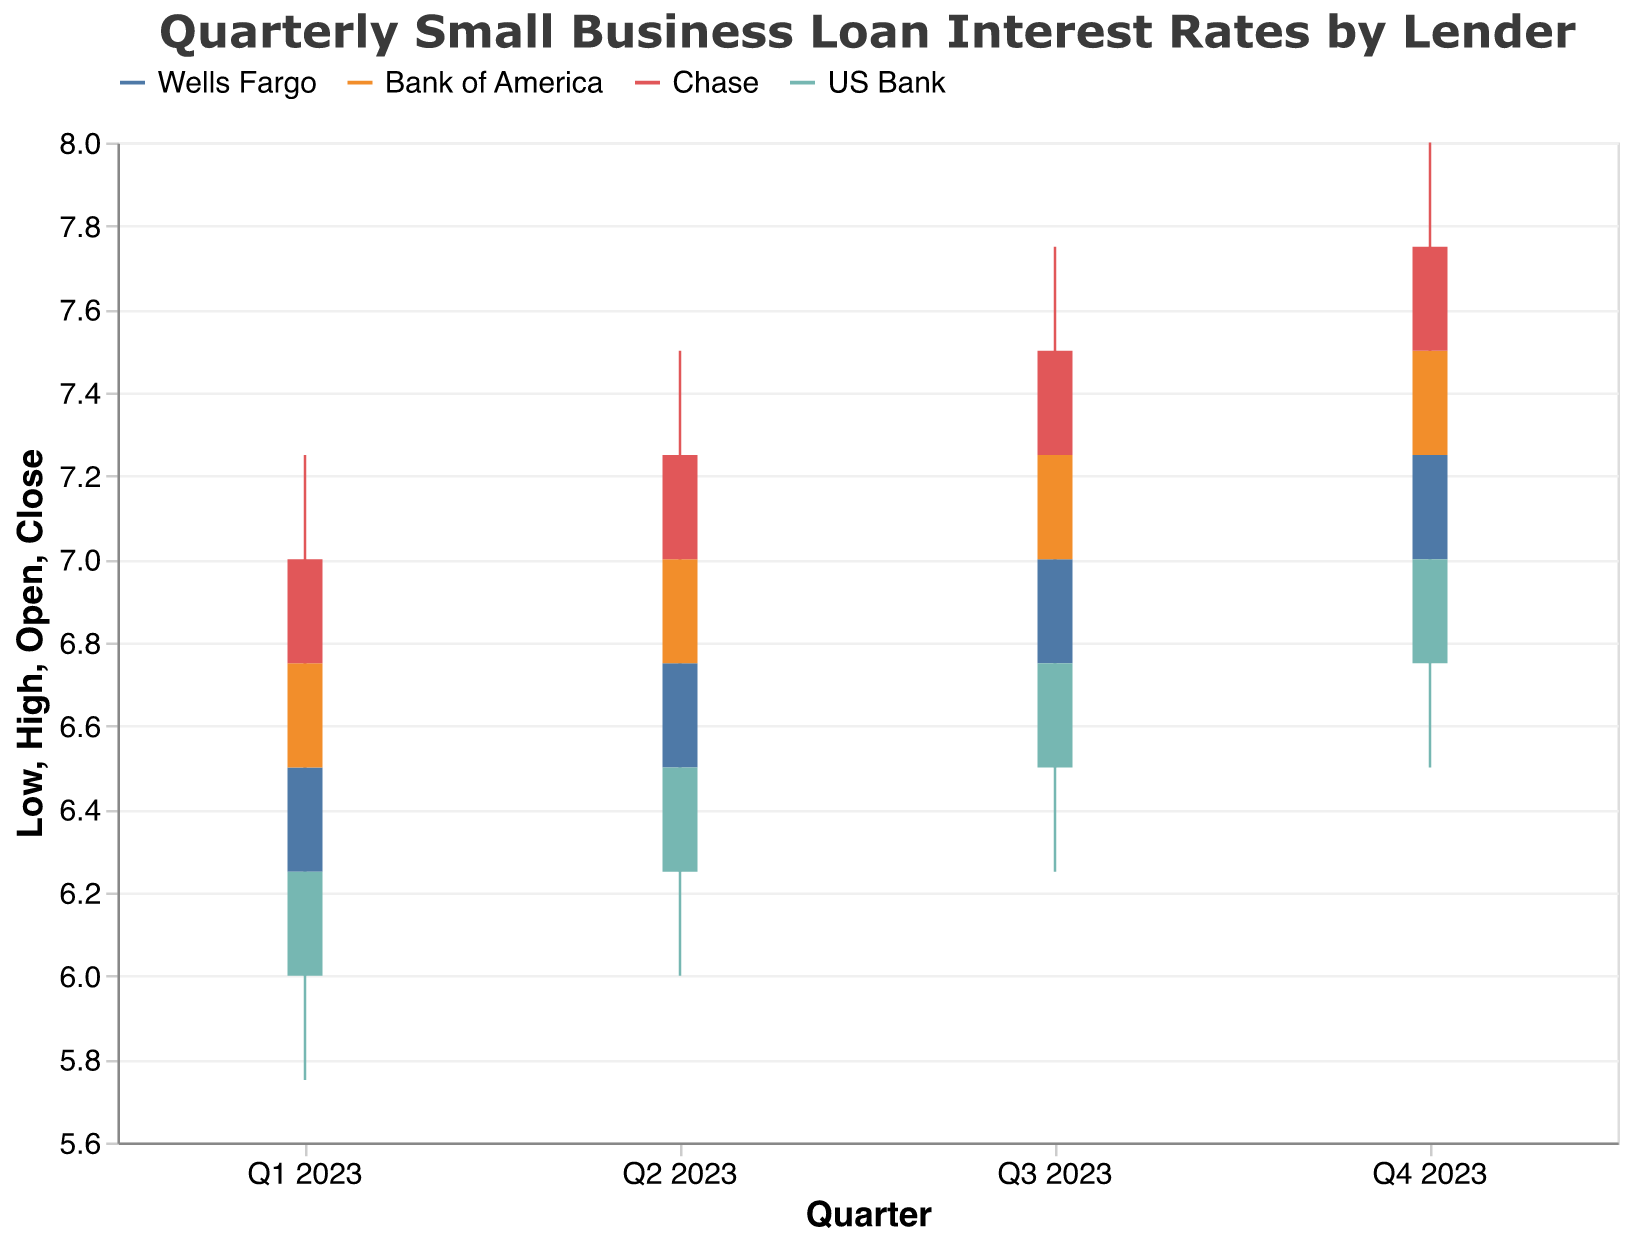What is the title of the figure? The title of the figure is usually placed at the top of the chart. In this case, it reads "Quarterly Small Business Loan Interest Rates by Lender" indicating it shows interest rates over quarters from different lenders.
Answer: Quarterly Small Business Loan Interest Rates by Lender Which lender has the highest closing interest rate in Q4 2023? In Q4 2023, the lender with the highest closing interest rate is determined by comparing the "Close" values for each lender in that quarter. Chase has the closing rate of 7.75.
Answer: Chase What is the opening interest rate for Bank of America in Q2 2023? To find the opening interest rate, we look at the "Open" value for Bank of America in Q2 2023 which is listed as 6.75.
Answer: 6.75 Which lender had the lowest high interest rate in Q1 2023? By comparing the "High" values for each lender in Q1 2023, US Bank has the lowest high interest rate, which is 6.50.
Answer: US Bank What was the range of interest rates (high minus low) for Wells Fargo in Q3 2023? To find the range, subtract the "Low" value from the "High" value for Wells Fargo in Q3 2023. The calculation is 7.25 - 6.50.
Answer: 0.75 Did Chase’s closing rate increase or decrease from Q2 2023 to Q3 2023, and by how much? To determine this, compare the "Close" values for Chase in Q2 and Q3 2023. In Q2 the close is 7.25 and in Q3 it is 7.50. Hence, the increase is calculated as 7.50 - 7.25.
Answer: Increase by 0.25 What was the trend of US Bank’s opening interest rate from Q1 2023 to Q4 2023? The opening rates for US Bank from Q1 to Q4 2023 are 6.00, 6.25, 6.50, and 6.75 respectively, indicating a steady increase each quarter.
Answer: Steady increase Which lender experienced the greatest difference between their high and low interest rates in any quarter? To find this, calculate the difference between the "High" and "Low" values for each lender in each quarter and compare. Chase in Q4 2023 has the greatest difference of 8.00 - 7.25.
Answer: Chase Did Wells Fargo’s closing rate ever exceed that of Bank of America in the same quarter? By comparing the "Close" values of both lenders across all quarters, Wells Fargo's closing rates are always equal to or lower than the closing rates of Bank of America.
Answer: No 